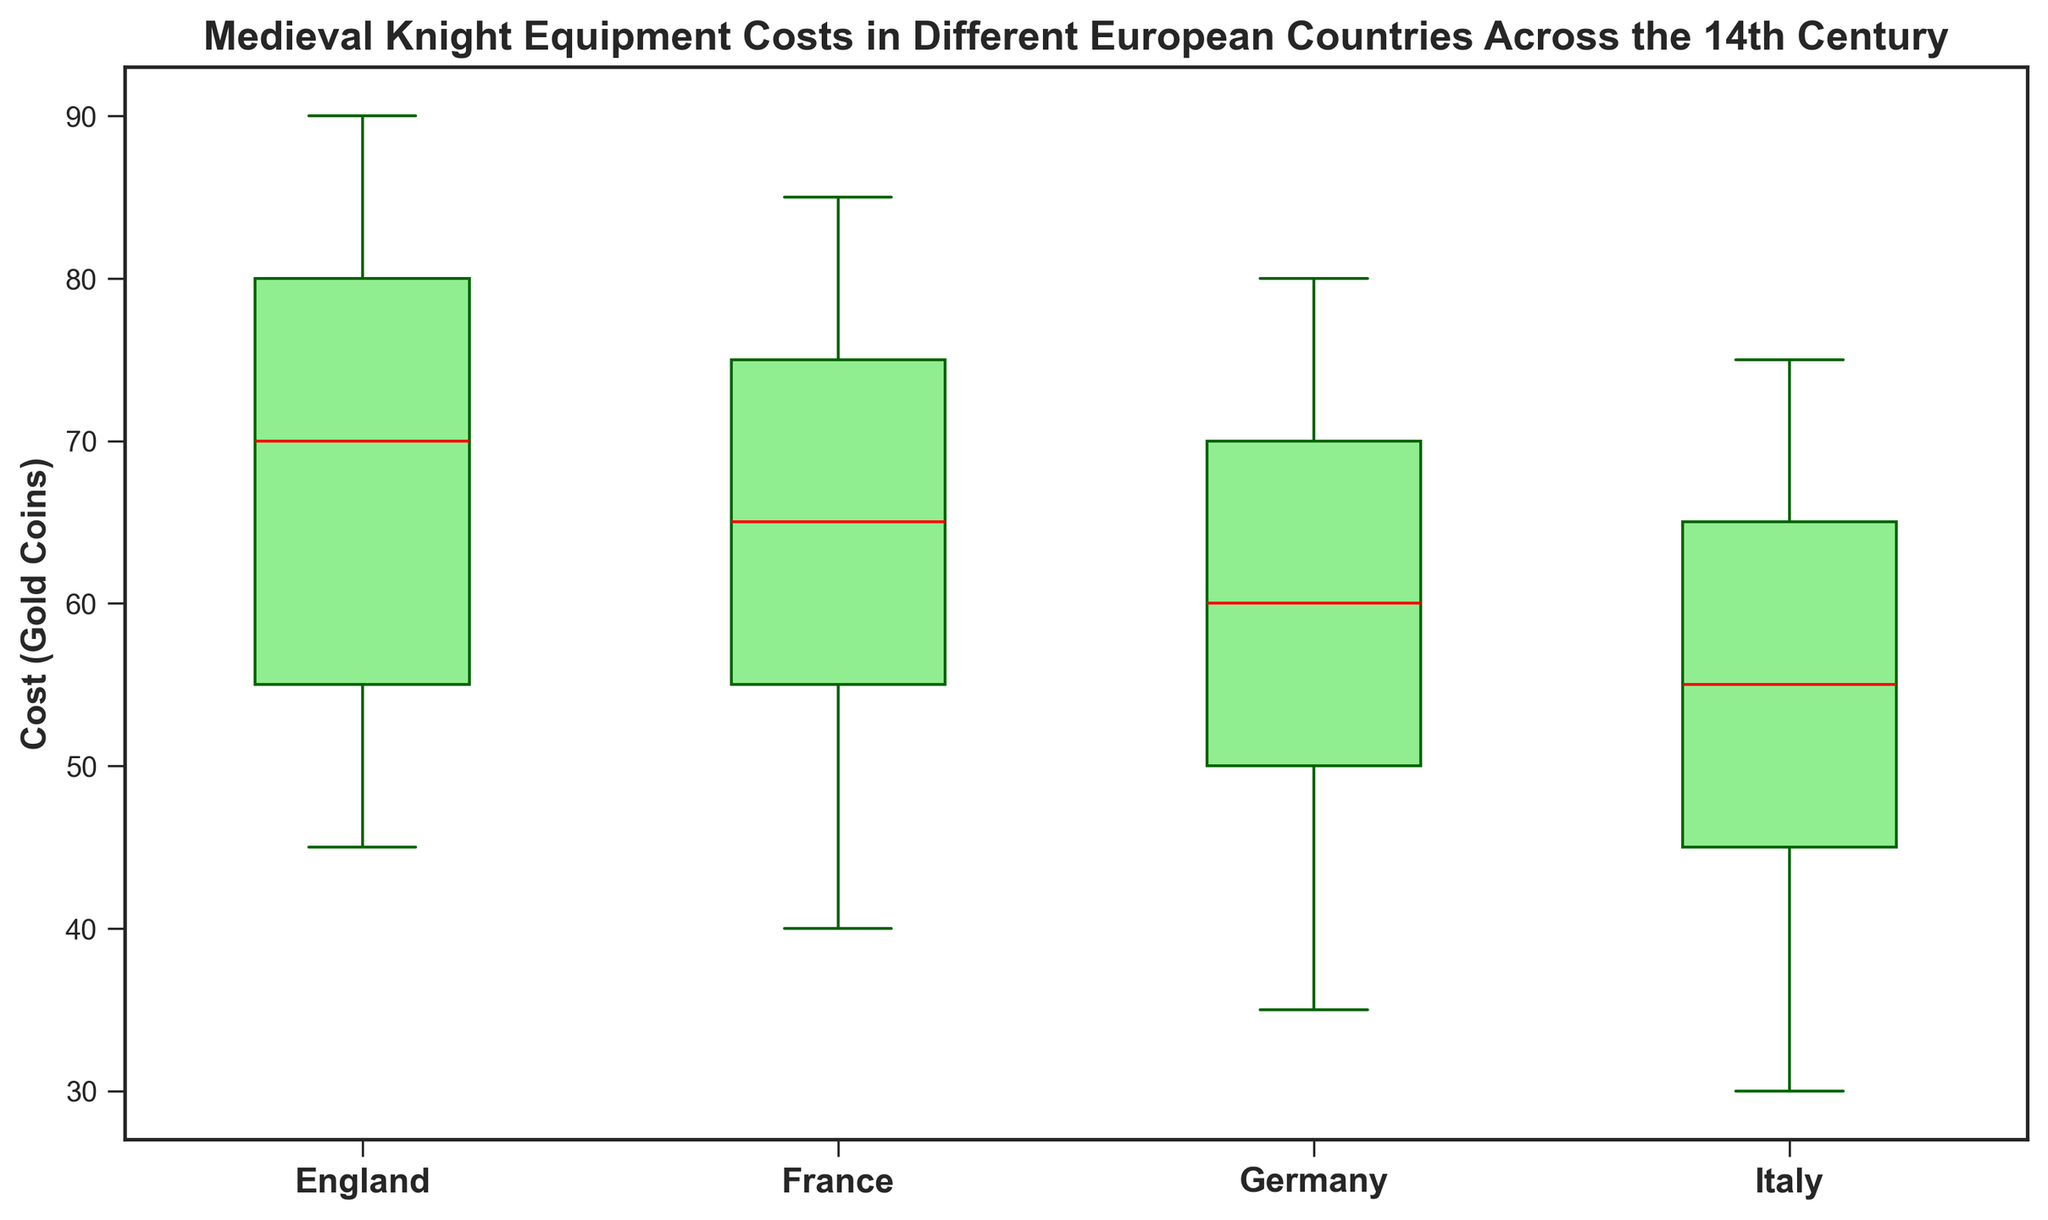what's the median cost of knight equipment in Germany? The median represents the middle value in a sorted data set. For Germany, sort the costs: [35, 45, 50, 55, 60, 65, 70, 75, 80]. The median is the fifth value, which is 60.
Answer: 60 Which country has the highest median cost for knight equipment? To determine this, compare the median values plotted for each country. The medians are indicated by the red lines inside each box. The highest red line corresponds to the highest median cost, which in this case is England.
Answer: England Among the countries displayed, which one shows the greatest variability in knight equipment costs? Variability is represented by the range between the whiskers in the box plot. Identify the country with the largest range between the lowest and highest whiskers. England has the widest range from 45 to 90.
Answer: England Between England and Italy, which country had a higher maximum cost for knight equipment? Maximum cost is represented by the top whisker in the box plot. For England, the top whisker reaches 90, while for Italy, it reaches 75. Therefore, England has the higher maximum cost.
Answer: England In which country is the median cost of knight equipment equal to the minimum cost in France? The median cost in Germany is 60. The minimum cost in France is also 40. Therefore, France's median cost is equal to France's minimum cost.
Answer: Germany How does the interquartile range (IQR) of England compare to that of France? The IQR is the difference between the third quartile (top edge of the box) and the first quartile (bottom edge of the box). For England, the IQR is the difference between 80 and 55 (25), and for France, it is the difference between 75 and 60 (15). Therefore, England's IQR is larger than France's.
Answer: England's IQR is larger Which country exhibits the least variation in knight equipment costs according to the box plot? Variation is represented by the length from the bottom whisker to the top whisker. The smallest range indicates the least variation. Italy has the smallest range from 30 to 75.
Answer: Italy What is the cost range (difference between the maximum and minimum) for knight equipment in France? Identify the maximum and minimum whisker values for France. The maximum is 85 and the minimum is 40. The range is 85 - 40 = 45.
Answer: 45 Did any country besides England and France have a median cost above 70? Check the red median lines of each country's box plot. Both England and France have medians above 70. Germany and Italy do not, as their medians are both 65 and below.
Answer: No 